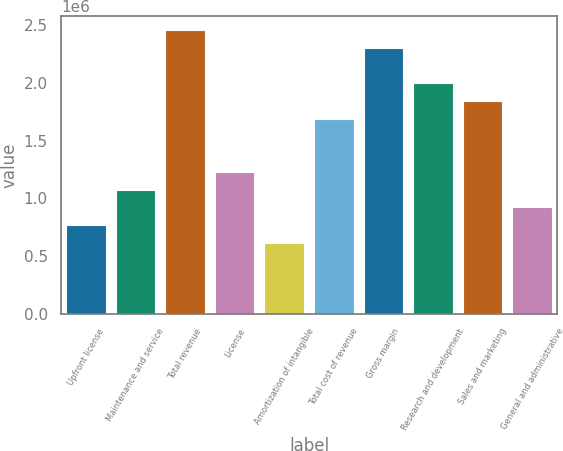Convert chart to OTSL. <chart><loc_0><loc_0><loc_500><loc_500><bar_chart><fcel>Upfront license<fcel>Maintenance and service<fcel>Total revenue<fcel>License<fcel>Amortization of intangible<fcel>Total cost of revenue<fcel>Gross margin<fcel>Research and development<fcel>Sales and marketing<fcel>General and administrative<nl><fcel>767822<fcel>1.07495e+06<fcel>2.45703e+06<fcel>1.22851e+06<fcel>614258<fcel>1.68921e+06<fcel>2.30346e+06<fcel>1.99634e+06<fcel>1.84277e+06<fcel>921386<nl></chart> 